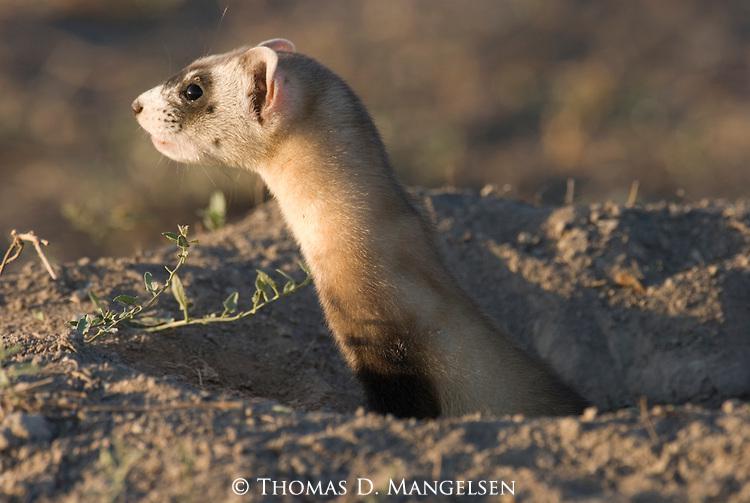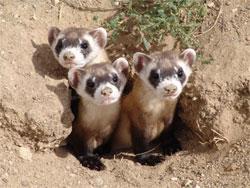The first image is the image on the left, the second image is the image on the right. Considering the images on both sides, is "A total of four ferrets are shown, all sticking their heads up above the surface of the ground." valid? Answer yes or no. Yes. The first image is the image on the left, the second image is the image on the right. Considering the images on both sides, is "There are exactly 4 animals." valid? Answer yes or no. Yes. 